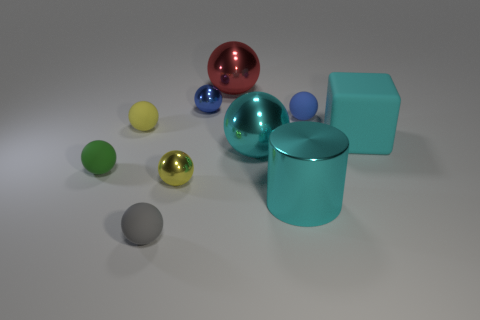What material is the gray thing that is the same shape as the tiny green thing?
Your response must be concise. Rubber. The tiny ball that is in front of the tiny blue metal thing and behind the yellow matte ball is what color?
Ensure brevity in your answer.  Blue. How many other things are there of the same material as the big cyan cylinder?
Make the answer very short. 4. Are there fewer small red metallic objects than objects?
Provide a short and direct response. Yes. Are the block and the ball that is behind the blue metal sphere made of the same material?
Offer a very short reply. No. What shape is the big object that is in front of the small yellow metal sphere?
Your answer should be compact. Cylinder. Is there anything else that is the same color as the large cube?
Ensure brevity in your answer.  Yes. Are there fewer small balls that are on the right side of the big red metallic ball than cyan matte objects?
Offer a very short reply. No. How many blocks have the same size as the yellow matte ball?
Your response must be concise. 0. There is a big rubber object that is the same color as the metal cylinder; what shape is it?
Your answer should be compact. Cube. 